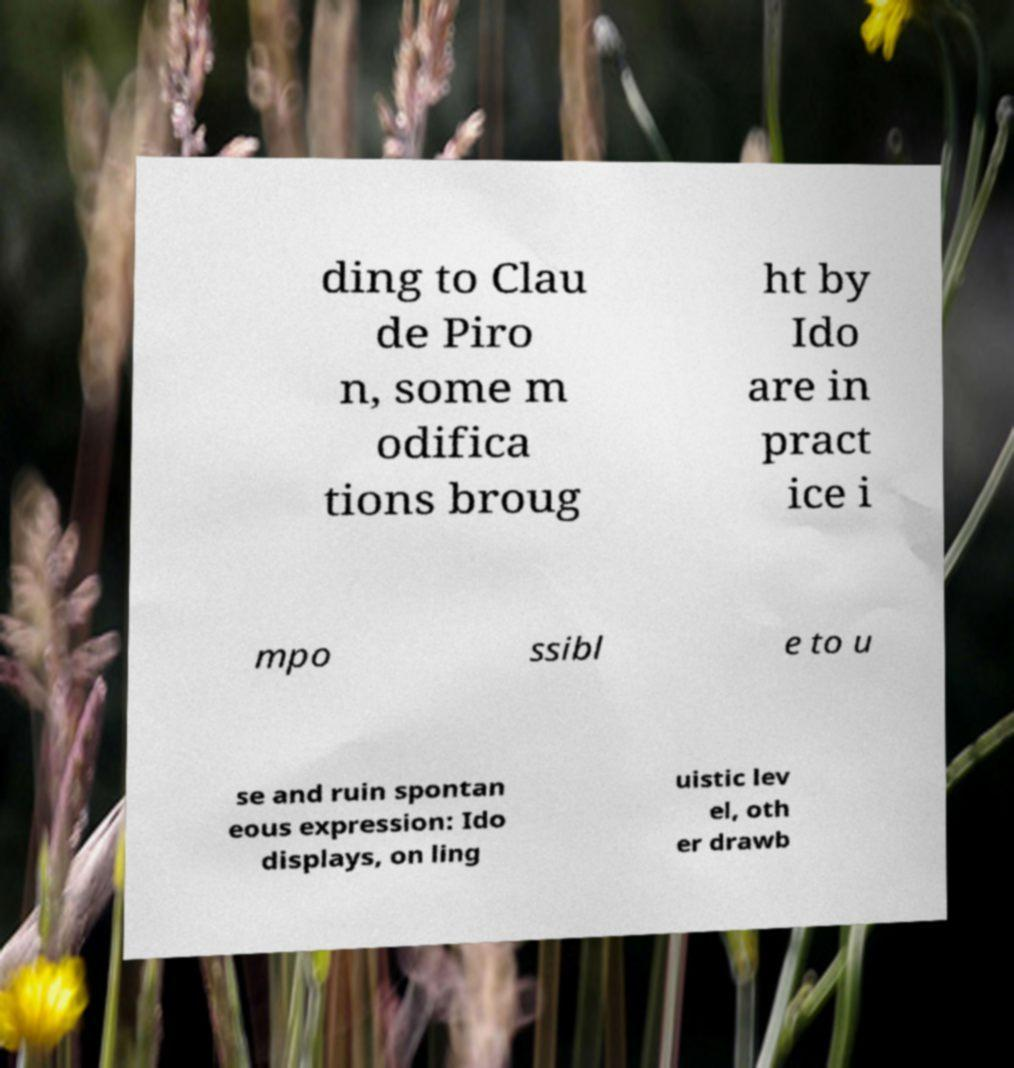Could you extract and type out the text from this image? ding to Clau de Piro n, some m odifica tions broug ht by Ido are in pract ice i mpo ssibl e to u se and ruin spontan eous expression: Ido displays, on ling uistic lev el, oth er drawb 